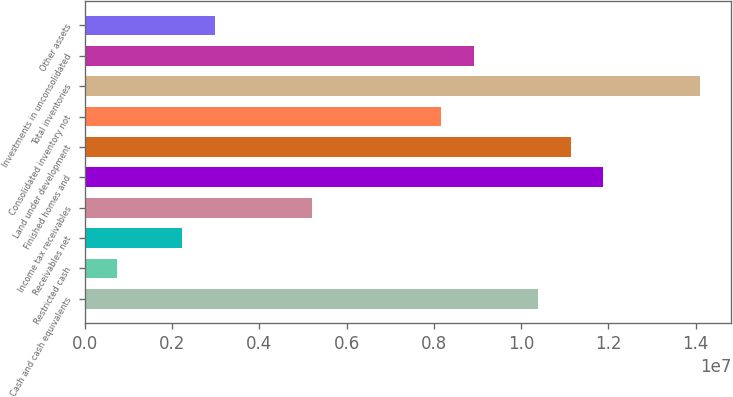Convert chart. <chart><loc_0><loc_0><loc_500><loc_500><bar_chart><fcel>Cash and cash equivalents<fcel>Restricted cash<fcel>Receivables net<fcel>Income tax receivables<fcel>Finished homes and<fcel>Land under development<fcel>Consolidated inventory not<fcel>Total inventories<fcel>Investments in unconsolidated<fcel>Other assets<nl><fcel>1.03935e+07<fcel>745456<fcel>2.22978e+06<fcel>5.19842e+06<fcel>1.18779e+07<fcel>1.11357e+07<fcel>8.16706e+06<fcel>1.41043e+07<fcel>8.90922e+06<fcel>2.97194e+06<nl></chart> 